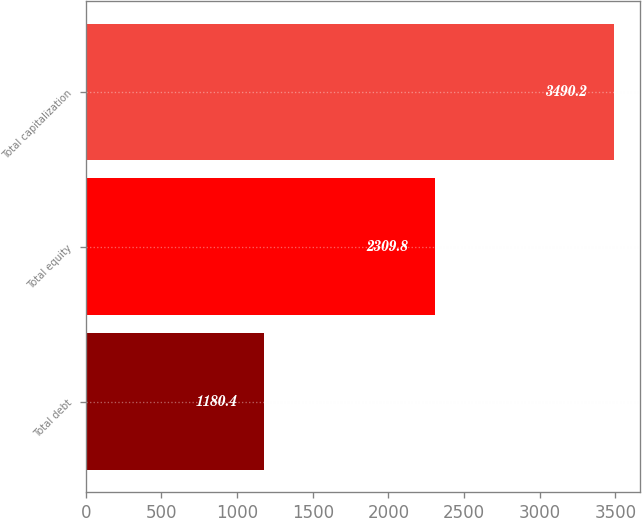Convert chart. <chart><loc_0><loc_0><loc_500><loc_500><bar_chart><fcel>Total debt<fcel>Total equity<fcel>Total capitalization<nl><fcel>1180.4<fcel>2309.8<fcel>3490.2<nl></chart> 